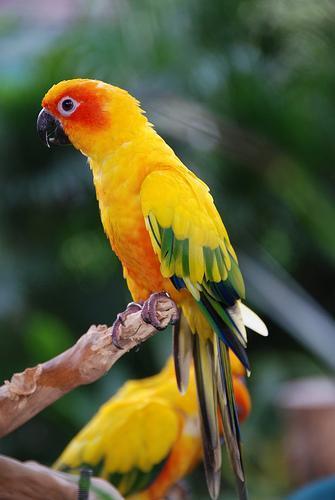How many colors can you see on this bird?
Give a very brief answer. 5. 